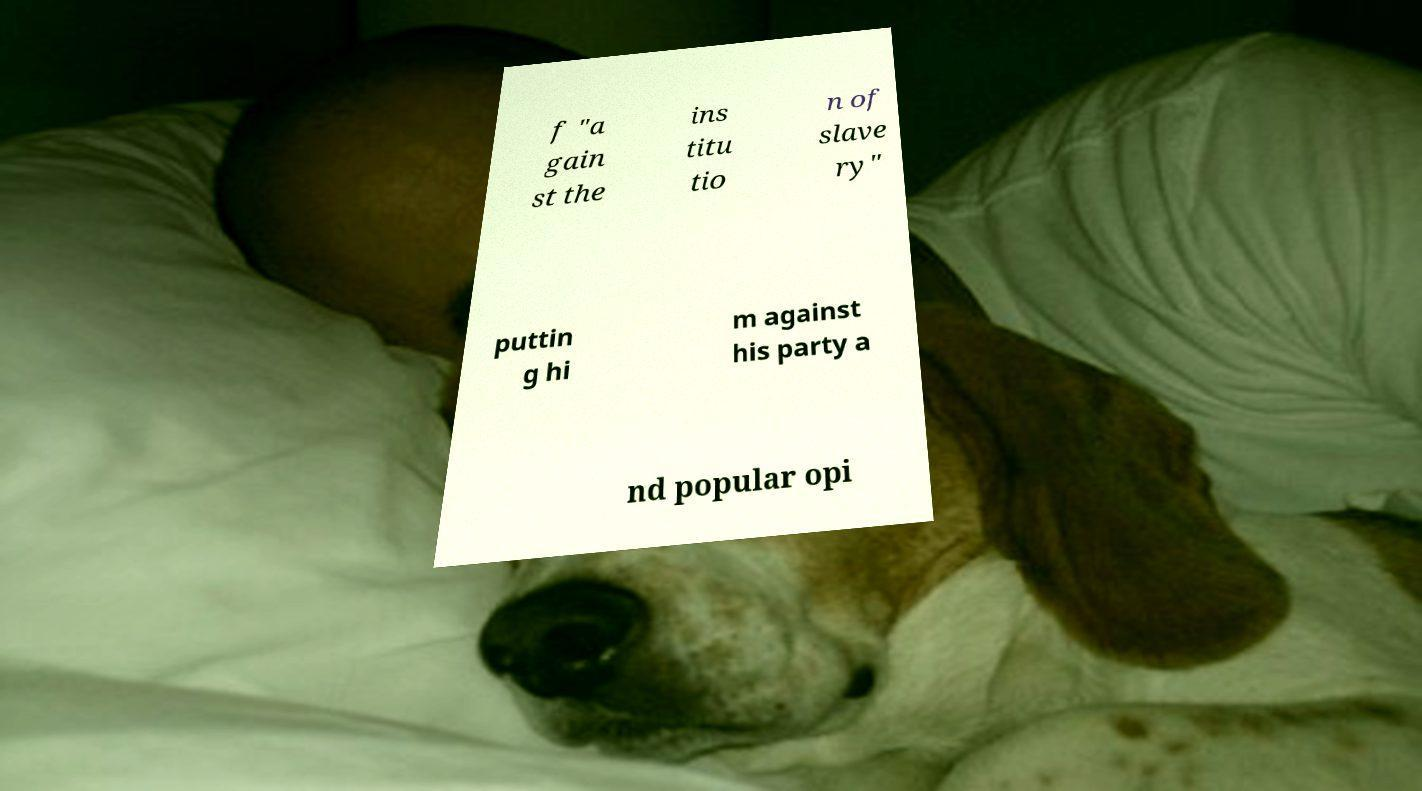I need the written content from this picture converted into text. Can you do that? f "a gain st the ins titu tio n of slave ry" puttin g hi m against his party a nd popular opi 